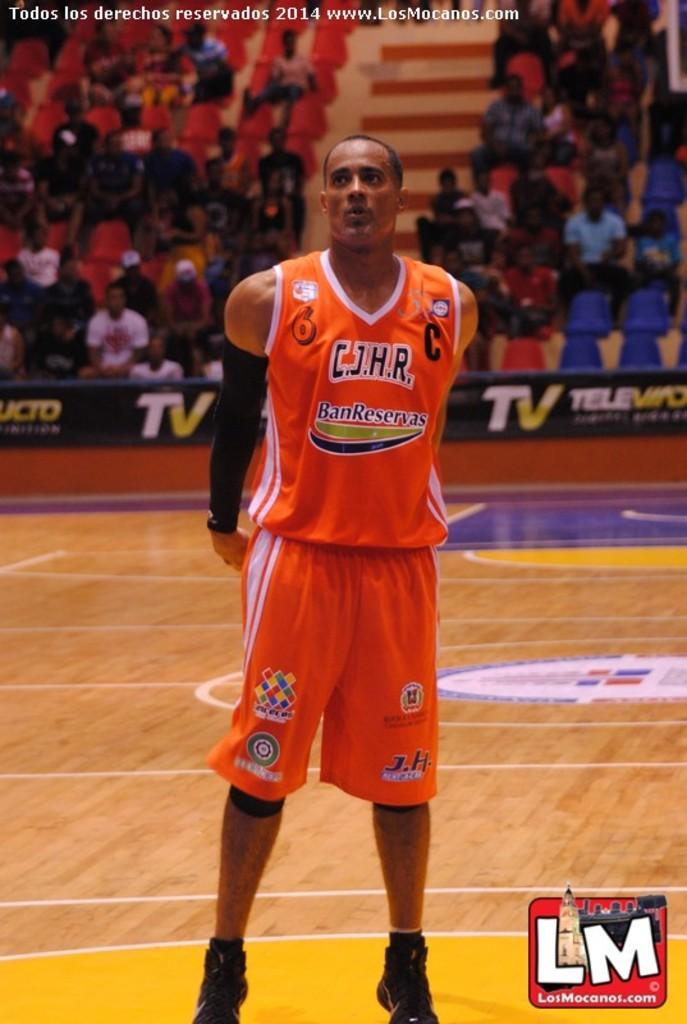Describe this image in one or two sentences. There is a man standing. In the back there are many people sitting on chairs. There are banners and there are steps. At the top something is written. In the right bottom corner there is a watermark. 